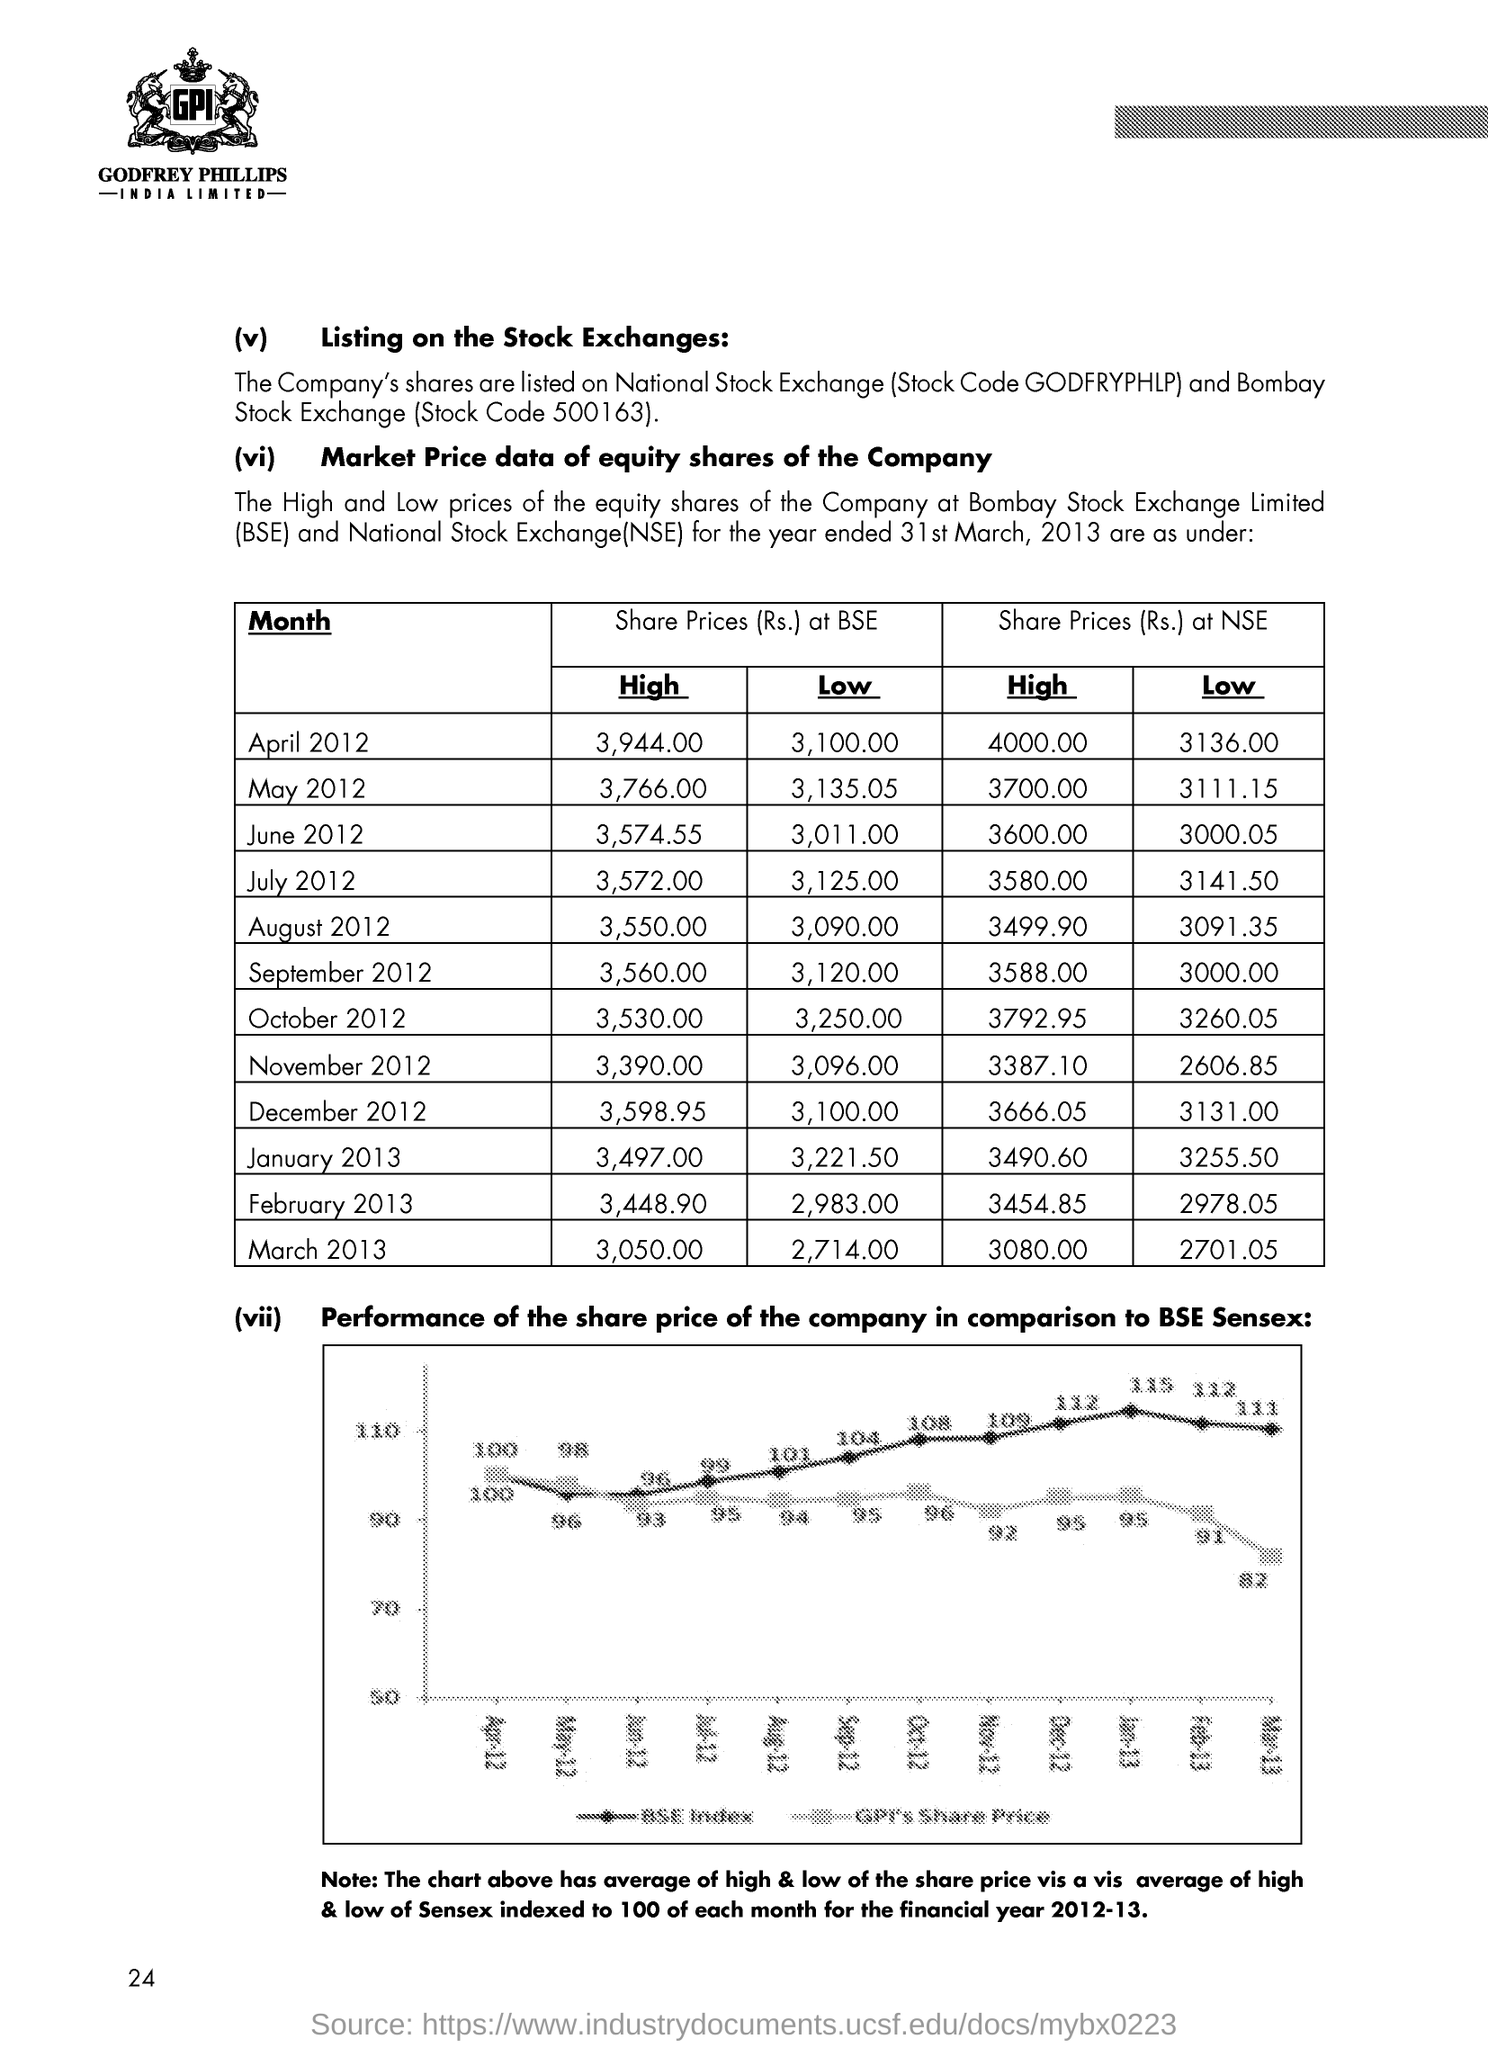Specify some key components in this picture. The full form of NSE is the National Stock Exchange. 